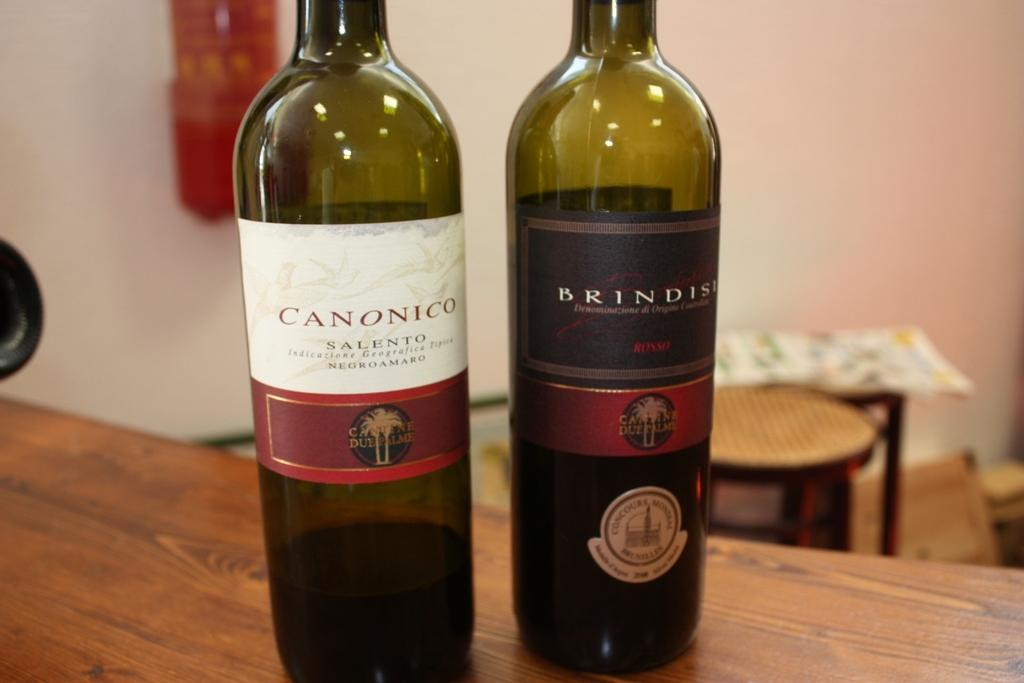<image>
Create a compact narrative representing the image presented. Bottles of Canonico and Brindisi wine stand on a table. 